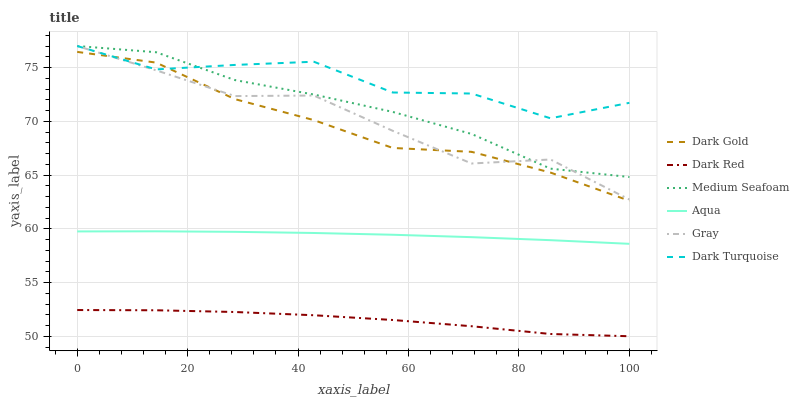Does Dark Red have the minimum area under the curve?
Answer yes or no. Yes. Does Dark Turquoise have the maximum area under the curve?
Answer yes or no. Yes. Does Dark Gold have the minimum area under the curve?
Answer yes or no. No. Does Dark Gold have the maximum area under the curve?
Answer yes or no. No. Is Aqua the smoothest?
Answer yes or no. Yes. Is Dark Turquoise the roughest?
Answer yes or no. Yes. Is Dark Gold the smoothest?
Answer yes or no. No. Is Dark Gold the roughest?
Answer yes or no. No. Does Dark Red have the lowest value?
Answer yes or no. Yes. Does Dark Gold have the lowest value?
Answer yes or no. No. Does Medium Seafoam have the highest value?
Answer yes or no. Yes. Does Dark Gold have the highest value?
Answer yes or no. No. Is Aqua less than Medium Seafoam?
Answer yes or no. Yes. Is Medium Seafoam greater than Dark Red?
Answer yes or no. Yes. Does Gray intersect Dark Turquoise?
Answer yes or no. Yes. Is Gray less than Dark Turquoise?
Answer yes or no. No. Is Gray greater than Dark Turquoise?
Answer yes or no. No. Does Aqua intersect Medium Seafoam?
Answer yes or no. No. 